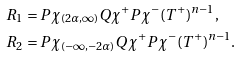<formula> <loc_0><loc_0><loc_500><loc_500>R _ { 1 } & = P \chi _ { ( 2 \alpha , \infty ) } Q \chi ^ { + } P \chi ^ { - } ( T ^ { + } ) ^ { n - 1 } , \\ R _ { 2 } & = P \chi _ { ( - \infty , - 2 \alpha ) } Q \chi ^ { + } P \chi ^ { - } ( T ^ { + } ) ^ { n - 1 } .</formula> 